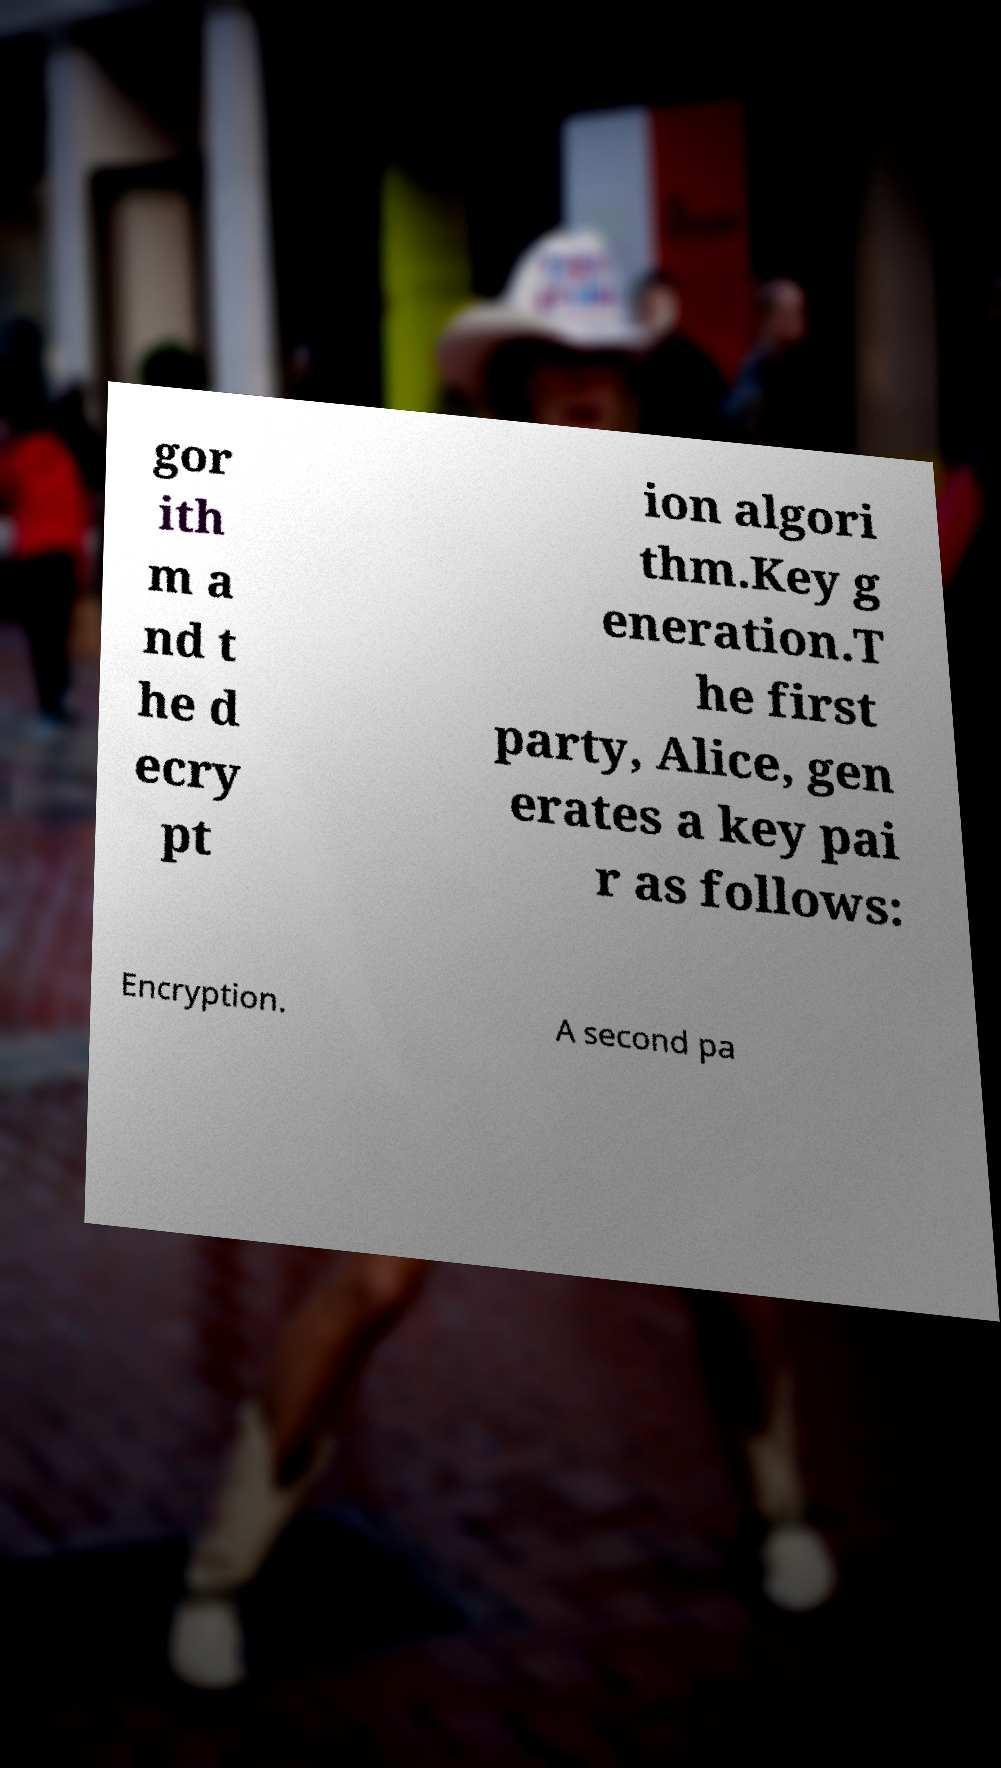Could you extract and type out the text from this image? gor ith m a nd t he d ecry pt ion algori thm.Key g eneration.T he first party, Alice, gen erates a key pai r as follows: Encryption. A second pa 